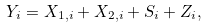Convert formula to latex. <formula><loc_0><loc_0><loc_500><loc_500>& Y _ { i } = X _ { 1 , i } + X _ { 2 , i } + S _ { i } + Z _ { i } ,</formula> 